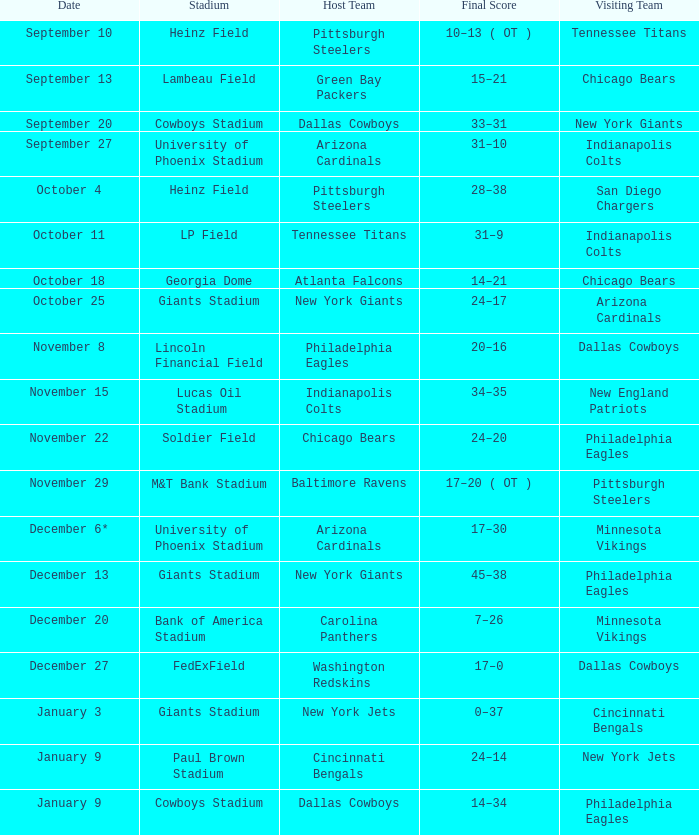Would you mind parsing the complete table? {'header': ['Date', 'Stadium', 'Host Team', 'Final Score', 'Visiting Team'], 'rows': [['September 10', 'Heinz Field', 'Pittsburgh Steelers', '10–13 ( OT )', 'Tennessee Titans'], ['September 13', 'Lambeau Field', 'Green Bay Packers', '15–21', 'Chicago Bears'], ['September 20', 'Cowboys Stadium', 'Dallas Cowboys', '33–31', 'New York Giants'], ['September 27', 'University of Phoenix Stadium', 'Arizona Cardinals', '31–10', 'Indianapolis Colts'], ['October 4', 'Heinz Field', 'Pittsburgh Steelers', '28–38', 'San Diego Chargers'], ['October 11', 'LP Field', 'Tennessee Titans', '31–9', 'Indianapolis Colts'], ['October 18', 'Georgia Dome', 'Atlanta Falcons', '14–21', 'Chicago Bears'], ['October 25', 'Giants Stadium', 'New York Giants', '24–17', 'Arizona Cardinals'], ['November 8', 'Lincoln Financial Field', 'Philadelphia Eagles', '20–16', 'Dallas Cowboys'], ['November 15', 'Lucas Oil Stadium', 'Indianapolis Colts', '34–35', 'New England Patriots'], ['November 22', 'Soldier Field', 'Chicago Bears', '24–20', 'Philadelphia Eagles'], ['November 29', 'M&T Bank Stadium', 'Baltimore Ravens', '17–20 ( OT )', 'Pittsburgh Steelers'], ['December 6*', 'University of Phoenix Stadium', 'Arizona Cardinals', '17–30', 'Minnesota Vikings'], ['December 13', 'Giants Stadium', 'New York Giants', '45–38', 'Philadelphia Eagles'], ['December 20', 'Bank of America Stadium', 'Carolina Panthers', '7–26', 'Minnesota Vikings'], ['December 27', 'FedExField', 'Washington Redskins', '17–0', 'Dallas Cowboys'], ['January 3', 'Giants Stadium', 'New York Jets', '0–37', 'Cincinnati Bengals'], ['January 9', 'Paul Brown Stadium', 'Cincinnati Bengals', '24–14', 'New York Jets'], ['January 9', 'Cowboys Stadium', 'Dallas Cowboys', '14–34', 'Philadelphia Eagles']]} Tell me the date for pittsburgh steelers November 29. 